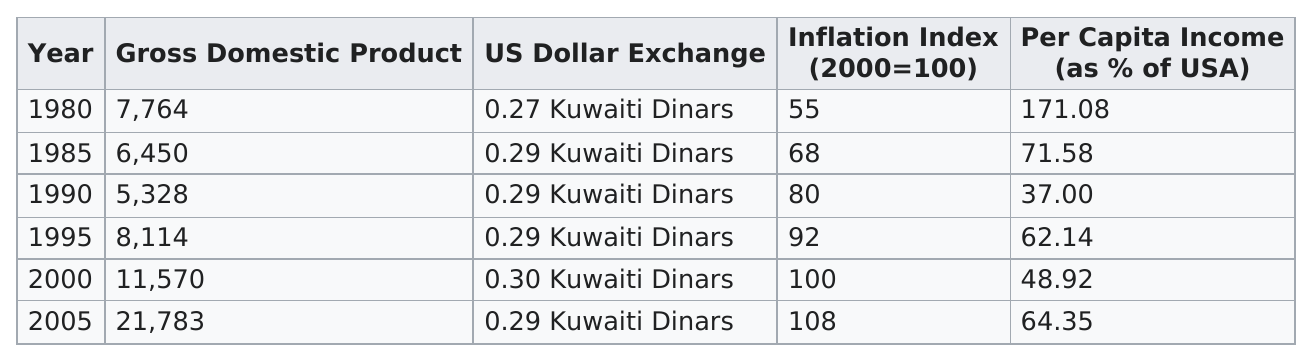List a handful of essential elements in this visual. The year with a Gross Domestic Product (GDP) between 8,114 and 21,783 is 2000. The Kuwaiti inflation index broke 100 two times. In 2005, there was a significant increase in the rate of inflation. The Gross Domestic Product was above 6,000 for a total of 5 years. In 2000, the Kuwaiti dinar reached its highest exchange rate against the US dollar. 